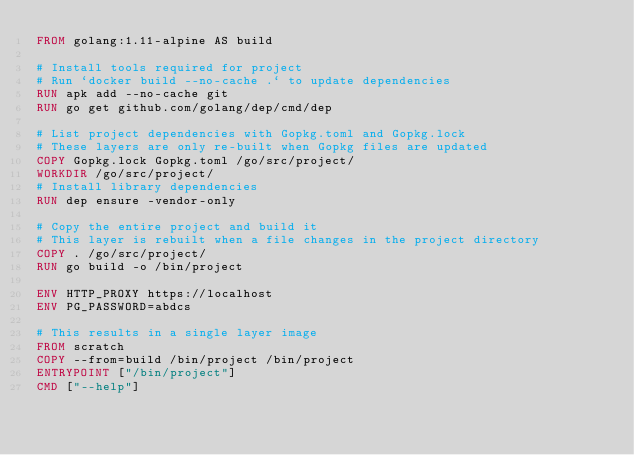<code> <loc_0><loc_0><loc_500><loc_500><_Dockerfile_>FROM golang:1.11-alpine AS build

# Install tools required for project
# Run `docker build --no-cache .` to update dependencies
RUN apk add --no-cache git
RUN go get github.com/golang/dep/cmd/dep

# List project dependencies with Gopkg.toml and Gopkg.lock
# These layers are only re-built when Gopkg files are updated
COPY Gopkg.lock Gopkg.toml /go/src/project/
WORKDIR /go/src/project/
# Install library dependencies
RUN dep ensure -vendor-only

# Copy the entire project and build it
# This layer is rebuilt when a file changes in the project directory
COPY . /go/src/project/
RUN go build -o /bin/project

ENV HTTP_PROXY https://localhost
ENV PG_PASSWORD=abdcs

# This results in a single layer image
FROM scratch
COPY --from=build /bin/project /bin/project
ENTRYPOINT ["/bin/project"]
CMD ["--help"]
</code> 